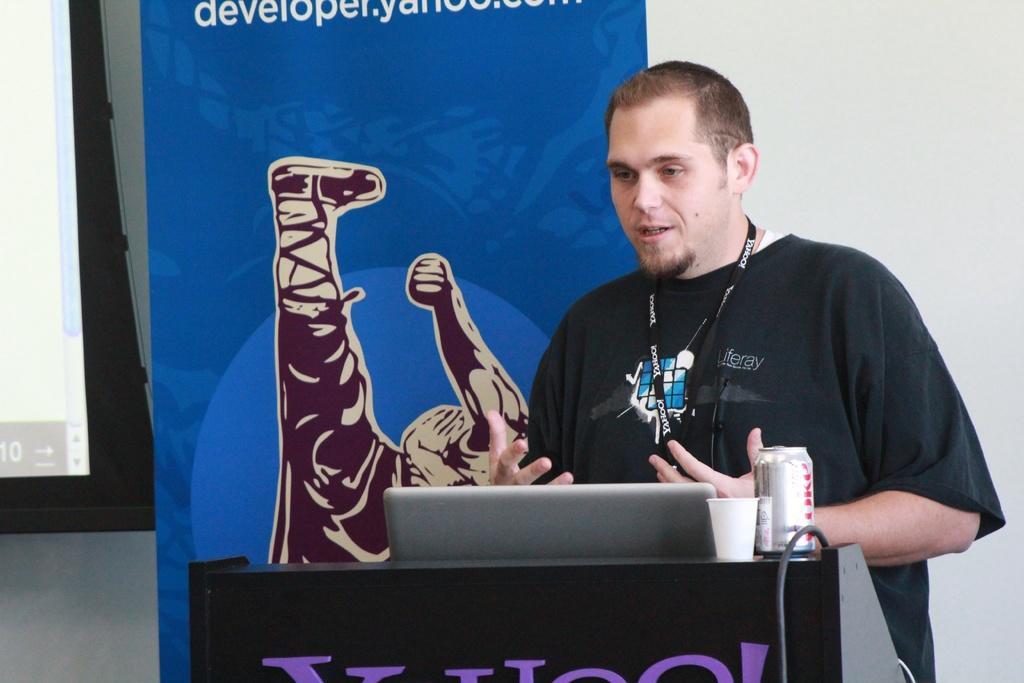Please provide a concise description of this image. In this picture we can see a man is standing in front of a podium, there is a laptop, a cup and a tin present on the podium, in the background there is a wall and some text, on the left side we can see a screen. 